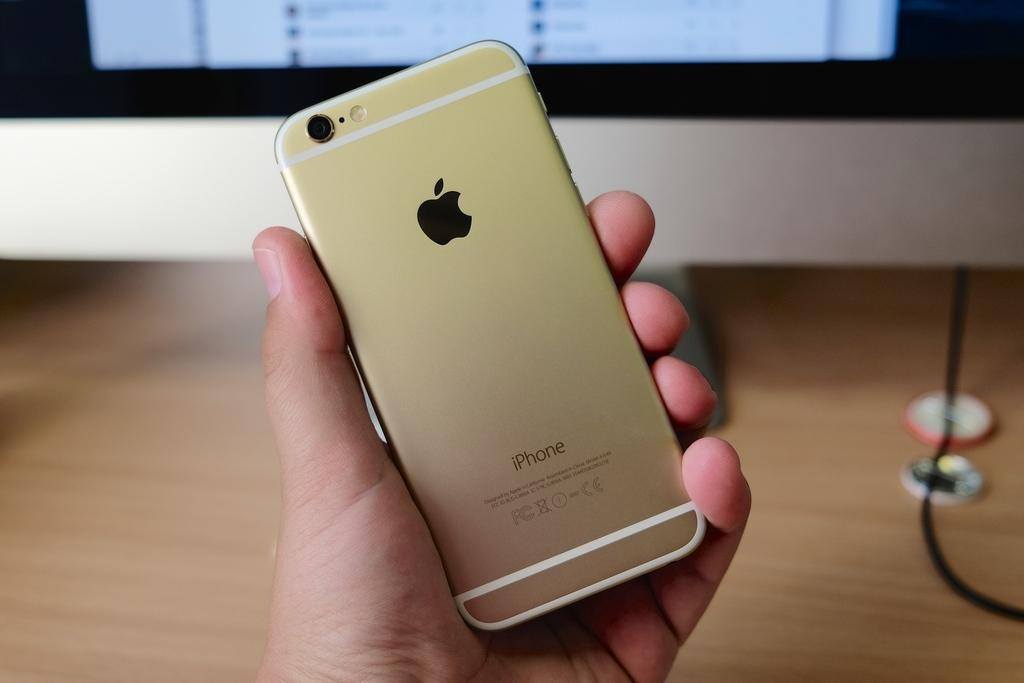What is the person holding in the image? There is a person's hand holding a phone in the image. What can be seen in the background of the image? There is a computer screen on a table in the background. What is located on the right side of the image? There is a cable on the right side of the image. What type of music can be heard playing from the airplane in the image? There is no airplane present in the image, so it is not possible to determine what music might be heard. 